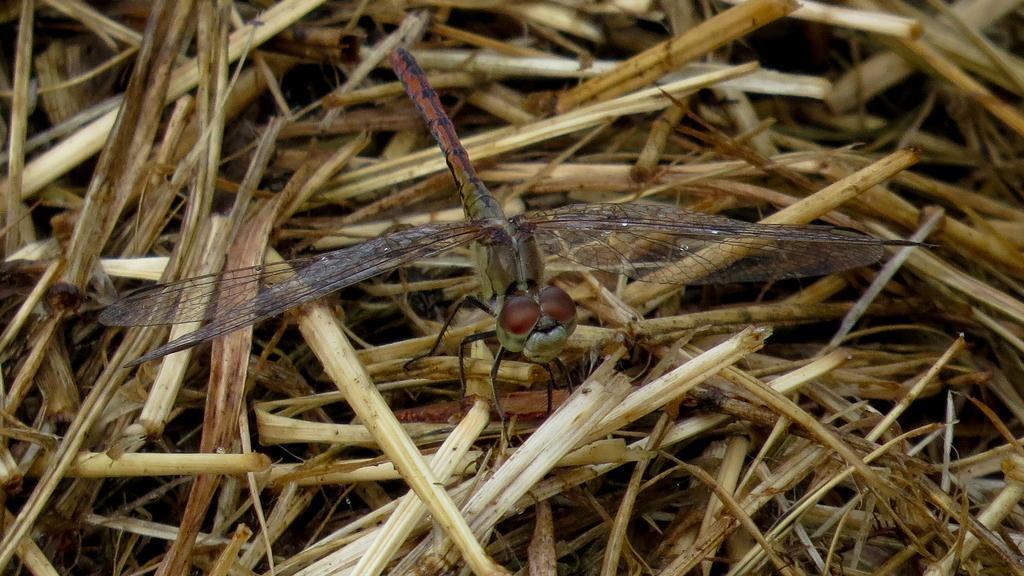What type of insect is present in the image? There is a dragonfly in the image. What is the dragonfly sitting on? The dragonfly is sitting on a dry plant stem. What type of watch is the dragonfly wearing in the image? There is no watch present in the image, as dragonflies do not wear watches. 